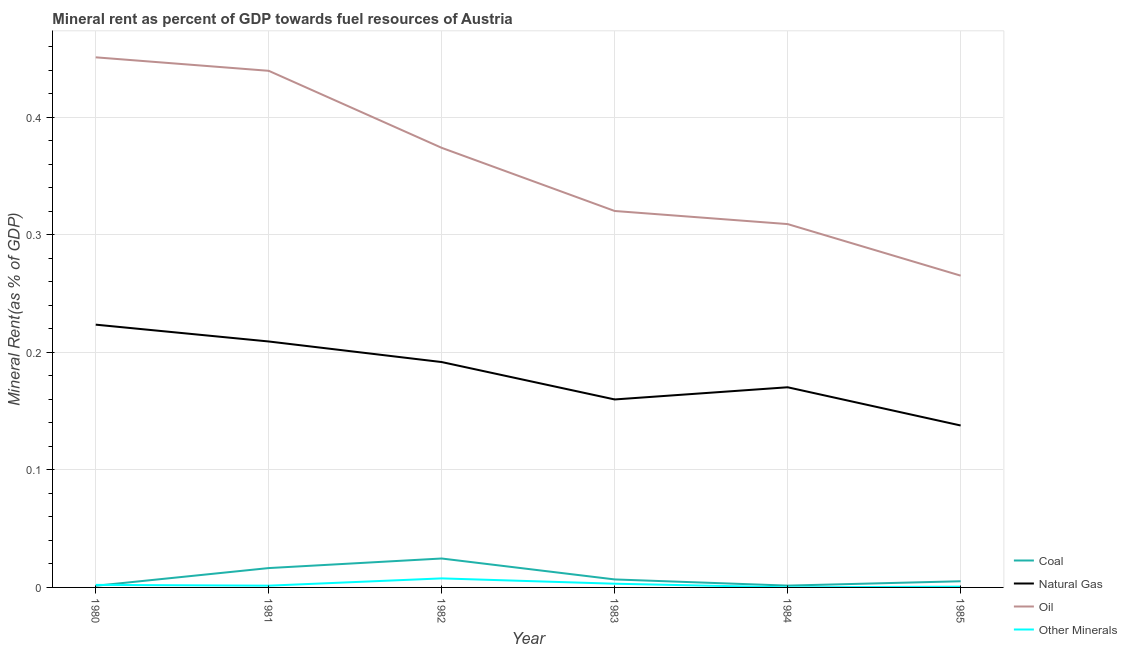What is the oil rent in 1981?
Provide a succinct answer. 0.44. Across all years, what is the maximum oil rent?
Keep it short and to the point. 0.45. Across all years, what is the minimum natural gas rent?
Your response must be concise. 0.14. In which year was the coal rent maximum?
Keep it short and to the point. 1982. In which year was the  rent of other minerals minimum?
Your answer should be compact. 1984. What is the total oil rent in the graph?
Your response must be concise. 2.16. What is the difference between the natural gas rent in 1980 and that in 1983?
Keep it short and to the point. 0.06. What is the difference between the oil rent in 1984 and the natural gas rent in 1981?
Offer a very short reply. 0.1. What is the average oil rent per year?
Your answer should be very brief. 0.36. In the year 1982, what is the difference between the natural gas rent and  rent of other minerals?
Give a very brief answer. 0.18. What is the ratio of the  rent of other minerals in 1981 to that in 1984?
Provide a succinct answer. 17.1. Is the difference between the coal rent in 1981 and 1985 greater than the difference between the oil rent in 1981 and 1985?
Your response must be concise. No. What is the difference between the highest and the second highest oil rent?
Ensure brevity in your answer.  0.01. What is the difference between the highest and the lowest natural gas rent?
Give a very brief answer. 0.09. Is the sum of the oil rent in 1981 and 1984 greater than the maximum natural gas rent across all years?
Keep it short and to the point. Yes. Does the  rent of other minerals monotonically increase over the years?
Give a very brief answer. No. Is the oil rent strictly greater than the coal rent over the years?
Ensure brevity in your answer.  Yes. How many years are there in the graph?
Ensure brevity in your answer.  6. What is the difference between two consecutive major ticks on the Y-axis?
Offer a very short reply. 0.1. Does the graph contain grids?
Offer a very short reply. Yes. Where does the legend appear in the graph?
Offer a very short reply. Bottom right. How many legend labels are there?
Provide a succinct answer. 4. How are the legend labels stacked?
Give a very brief answer. Vertical. What is the title of the graph?
Your answer should be compact. Mineral rent as percent of GDP towards fuel resources of Austria. What is the label or title of the X-axis?
Ensure brevity in your answer.  Year. What is the label or title of the Y-axis?
Your answer should be compact. Mineral Rent(as % of GDP). What is the Mineral Rent(as % of GDP) of Coal in 1980?
Make the answer very short. 0. What is the Mineral Rent(as % of GDP) of Natural Gas in 1980?
Give a very brief answer. 0.22. What is the Mineral Rent(as % of GDP) of Oil in 1980?
Keep it short and to the point. 0.45. What is the Mineral Rent(as % of GDP) of Other Minerals in 1980?
Ensure brevity in your answer.  0. What is the Mineral Rent(as % of GDP) of Coal in 1981?
Offer a terse response. 0.02. What is the Mineral Rent(as % of GDP) of Natural Gas in 1981?
Offer a terse response. 0.21. What is the Mineral Rent(as % of GDP) of Oil in 1981?
Your answer should be very brief. 0.44. What is the Mineral Rent(as % of GDP) of Other Minerals in 1981?
Provide a succinct answer. 0. What is the Mineral Rent(as % of GDP) of Coal in 1982?
Keep it short and to the point. 0.02. What is the Mineral Rent(as % of GDP) of Natural Gas in 1982?
Offer a terse response. 0.19. What is the Mineral Rent(as % of GDP) in Oil in 1982?
Provide a succinct answer. 0.37. What is the Mineral Rent(as % of GDP) in Other Minerals in 1982?
Ensure brevity in your answer.  0.01. What is the Mineral Rent(as % of GDP) in Coal in 1983?
Your response must be concise. 0.01. What is the Mineral Rent(as % of GDP) in Natural Gas in 1983?
Offer a terse response. 0.16. What is the Mineral Rent(as % of GDP) of Oil in 1983?
Keep it short and to the point. 0.32. What is the Mineral Rent(as % of GDP) of Other Minerals in 1983?
Make the answer very short. 0. What is the Mineral Rent(as % of GDP) of Coal in 1984?
Offer a terse response. 0. What is the Mineral Rent(as % of GDP) of Natural Gas in 1984?
Your answer should be compact. 0.17. What is the Mineral Rent(as % of GDP) in Oil in 1984?
Your answer should be very brief. 0.31. What is the Mineral Rent(as % of GDP) in Other Minerals in 1984?
Provide a succinct answer. 8.70112299928104e-5. What is the Mineral Rent(as % of GDP) in Coal in 1985?
Provide a succinct answer. 0.01. What is the Mineral Rent(as % of GDP) in Natural Gas in 1985?
Your answer should be compact. 0.14. What is the Mineral Rent(as % of GDP) of Oil in 1985?
Provide a short and direct response. 0.27. What is the Mineral Rent(as % of GDP) of Other Minerals in 1985?
Offer a very short reply. 0. Across all years, what is the maximum Mineral Rent(as % of GDP) in Coal?
Offer a very short reply. 0.02. Across all years, what is the maximum Mineral Rent(as % of GDP) in Natural Gas?
Provide a succinct answer. 0.22. Across all years, what is the maximum Mineral Rent(as % of GDP) of Oil?
Give a very brief answer. 0.45. Across all years, what is the maximum Mineral Rent(as % of GDP) of Other Minerals?
Make the answer very short. 0.01. Across all years, what is the minimum Mineral Rent(as % of GDP) in Coal?
Provide a succinct answer. 0. Across all years, what is the minimum Mineral Rent(as % of GDP) in Natural Gas?
Your response must be concise. 0.14. Across all years, what is the minimum Mineral Rent(as % of GDP) of Oil?
Make the answer very short. 0.27. Across all years, what is the minimum Mineral Rent(as % of GDP) of Other Minerals?
Provide a succinct answer. 8.70112299928104e-5. What is the total Mineral Rent(as % of GDP) of Coal in the graph?
Make the answer very short. 0.06. What is the total Mineral Rent(as % of GDP) of Natural Gas in the graph?
Your answer should be very brief. 1.09. What is the total Mineral Rent(as % of GDP) of Oil in the graph?
Your answer should be compact. 2.16. What is the total Mineral Rent(as % of GDP) of Other Minerals in the graph?
Ensure brevity in your answer.  0.02. What is the difference between the Mineral Rent(as % of GDP) of Coal in 1980 and that in 1981?
Keep it short and to the point. -0.02. What is the difference between the Mineral Rent(as % of GDP) of Natural Gas in 1980 and that in 1981?
Ensure brevity in your answer.  0.01. What is the difference between the Mineral Rent(as % of GDP) of Oil in 1980 and that in 1981?
Offer a terse response. 0.01. What is the difference between the Mineral Rent(as % of GDP) in Other Minerals in 1980 and that in 1981?
Your response must be concise. 0. What is the difference between the Mineral Rent(as % of GDP) of Coal in 1980 and that in 1982?
Provide a short and direct response. -0.02. What is the difference between the Mineral Rent(as % of GDP) of Natural Gas in 1980 and that in 1982?
Make the answer very short. 0.03. What is the difference between the Mineral Rent(as % of GDP) of Oil in 1980 and that in 1982?
Offer a terse response. 0.08. What is the difference between the Mineral Rent(as % of GDP) of Other Minerals in 1980 and that in 1982?
Your response must be concise. -0.01. What is the difference between the Mineral Rent(as % of GDP) of Coal in 1980 and that in 1983?
Offer a very short reply. -0.01. What is the difference between the Mineral Rent(as % of GDP) of Natural Gas in 1980 and that in 1983?
Your response must be concise. 0.06. What is the difference between the Mineral Rent(as % of GDP) in Oil in 1980 and that in 1983?
Keep it short and to the point. 0.13. What is the difference between the Mineral Rent(as % of GDP) of Other Minerals in 1980 and that in 1983?
Give a very brief answer. -0. What is the difference between the Mineral Rent(as % of GDP) in Coal in 1980 and that in 1984?
Your answer should be compact. -0. What is the difference between the Mineral Rent(as % of GDP) in Natural Gas in 1980 and that in 1984?
Your answer should be compact. 0.05. What is the difference between the Mineral Rent(as % of GDP) of Oil in 1980 and that in 1984?
Make the answer very short. 0.14. What is the difference between the Mineral Rent(as % of GDP) of Other Minerals in 1980 and that in 1984?
Offer a terse response. 0. What is the difference between the Mineral Rent(as % of GDP) in Coal in 1980 and that in 1985?
Provide a succinct answer. -0. What is the difference between the Mineral Rent(as % of GDP) in Natural Gas in 1980 and that in 1985?
Provide a short and direct response. 0.09. What is the difference between the Mineral Rent(as % of GDP) in Oil in 1980 and that in 1985?
Offer a terse response. 0.19. What is the difference between the Mineral Rent(as % of GDP) of Other Minerals in 1980 and that in 1985?
Ensure brevity in your answer.  0. What is the difference between the Mineral Rent(as % of GDP) in Coal in 1981 and that in 1982?
Ensure brevity in your answer.  -0.01. What is the difference between the Mineral Rent(as % of GDP) of Natural Gas in 1981 and that in 1982?
Offer a terse response. 0.02. What is the difference between the Mineral Rent(as % of GDP) of Oil in 1981 and that in 1982?
Provide a succinct answer. 0.07. What is the difference between the Mineral Rent(as % of GDP) in Other Minerals in 1981 and that in 1982?
Your response must be concise. -0.01. What is the difference between the Mineral Rent(as % of GDP) in Coal in 1981 and that in 1983?
Ensure brevity in your answer.  0.01. What is the difference between the Mineral Rent(as % of GDP) of Natural Gas in 1981 and that in 1983?
Make the answer very short. 0.05. What is the difference between the Mineral Rent(as % of GDP) of Oil in 1981 and that in 1983?
Ensure brevity in your answer.  0.12. What is the difference between the Mineral Rent(as % of GDP) of Other Minerals in 1981 and that in 1983?
Provide a short and direct response. -0. What is the difference between the Mineral Rent(as % of GDP) in Coal in 1981 and that in 1984?
Keep it short and to the point. 0.01. What is the difference between the Mineral Rent(as % of GDP) of Natural Gas in 1981 and that in 1984?
Ensure brevity in your answer.  0.04. What is the difference between the Mineral Rent(as % of GDP) of Oil in 1981 and that in 1984?
Give a very brief answer. 0.13. What is the difference between the Mineral Rent(as % of GDP) in Other Minerals in 1981 and that in 1984?
Ensure brevity in your answer.  0. What is the difference between the Mineral Rent(as % of GDP) in Coal in 1981 and that in 1985?
Your response must be concise. 0.01. What is the difference between the Mineral Rent(as % of GDP) of Natural Gas in 1981 and that in 1985?
Keep it short and to the point. 0.07. What is the difference between the Mineral Rent(as % of GDP) in Oil in 1981 and that in 1985?
Your response must be concise. 0.17. What is the difference between the Mineral Rent(as % of GDP) of Other Minerals in 1981 and that in 1985?
Your response must be concise. 0. What is the difference between the Mineral Rent(as % of GDP) of Coal in 1982 and that in 1983?
Make the answer very short. 0.02. What is the difference between the Mineral Rent(as % of GDP) in Natural Gas in 1982 and that in 1983?
Provide a succinct answer. 0.03. What is the difference between the Mineral Rent(as % of GDP) of Oil in 1982 and that in 1983?
Ensure brevity in your answer.  0.05. What is the difference between the Mineral Rent(as % of GDP) of Other Minerals in 1982 and that in 1983?
Keep it short and to the point. 0. What is the difference between the Mineral Rent(as % of GDP) in Coal in 1982 and that in 1984?
Your answer should be compact. 0.02. What is the difference between the Mineral Rent(as % of GDP) in Natural Gas in 1982 and that in 1984?
Offer a very short reply. 0.02. What is the difference between the Mineral Rent(as % of GDP) in Oil in 1982 and that in 1984?
Ensure brevity in your answer.  0.06. What is the difference between the Mineral Rent(as % of GDP) in Other Minerals in 1982 and that in 1984?
Offer a terse response. 0.01. What is the difference between the Mineral Rent(as % of GDP) of Coal in 1982 and that in 1985?
Ensure brevity in your answer.  0.02. What is the difference between the Mineral Rent(as % of GDP) in Natural Gas in 1982 and that in 1985?
Ensure brevity in your answer.  0.05. What is the difference between the Mineral Rent(as % of GDP) of Oil in 1982 and that in 1985?
Ensure brevity in your answer.  0.11. What is the difference between the Mineral Rent(as % of GDP) of Other Minerals in 1982 and that in 1985?
Keep it short and to the point. 0.01. What is the difference between the Mineral Rent(as % of GDP) in Coal in 1983 and that in 1984?
Your response must be concise. 0.01. What is the difference between the Mineral Rent(as % of GDP) of Natural Gas in 1983 and that in 1984?
Give a very brief answer. -0.01. What is the difference between the Mineral Rent(as % of GDP) in Oil in 1983 and that in 1984?
Keep it short and to the point. 0.01. What is the difference between the Mineral Rent(as % of GDP) of Other Minerals in 1983 and that in 1984?
Provide a succinct answer. 0. What is the difference between the Mineral Rent(as % of GDP) of Coal in 1983 and that in 1985?
Give a very brief answer. 0. What is the difference between the Mineral Rent(as % of GDP) in Natural Gas in 1983 and that in 1985?
Your answer should be very brief. 0.02. What is the difference between the Mineral Rent(as % of GDP) of Oil in 1983 and that in 1985?
Make the answer very short. 0.06. What is the difference between the Mineral Rent(as % of GDP) in Other Minerals in 1983 and that in 1985?
Keep it short and to the point. 0. What is the difference between the Mineral Rent(as % of GDP) of Coal in 1984 and that in 1985?
Provide a succinct answer. -0. What is the difference between the Mineral Rent(as % of GDP) of Natural Gas in 1984 and that in 1985?
Make the answer very short. 0.03. What is the difference between the Mineral Rent(as % of GDP) of Oil in 1984 and that in 1985?
Your answer should be very brief. 0.04. What is the difference between the Mineral Rent(as % of GDP) of Other Minerals in 1984 and that in 1985?
Offer a very short reply. -0. What is the difference between the Mineral Rent(as % of GDP) in Coal in 1980 and the Mineral Rent(as % of GDP) in Natural Gas in 1981?
Offer a very short reply. -0.21. What is the difference between the Mineral Rent(as % of GDP) in Coal in 1980 and the Mineral Rent(as % of GDP) in Oil in 1981?
Your response must be concise. -0.44. What is the difference between the Mineral Rent(as % of GDP) of Coal in 1980 and the Mineral Rent(as % of GDP) of Other Minerals in 1981?
Provide a short and direct response. -0. What is the difference between the Mineral Rent(as % of GDP) of Natural Gas in 1980 and the Mineral Rent(as % of GDP) of Oil in 1981?
Give a very brief answer. -0.22. What is the difference between the Mineral Rent(as % of GDP) of Natural Gas in 1980 and the Mineral Rent(as % of GDP) of Other Minerals in 1981?
Your answer should be very brief. 0.22. What is the difference between the Mineral Rent(as % of GDP) in Oil in 1980 and the Mineral Rent(as % of GDP) in Other Minerals in 1981?
Ensure brevity in your answer.  0.45. What is the difference between the Mineral Rent(as % of GDP) of Coal in 1980 and the Mineral Rent(as % of GDP) of Natural Gas in 1982?
Offer a very short reply. -0.19. What is the difference between the Mineral Rent(as % of GDP) of Coal in 1980 and the Mineral Rent(as % of GDP) of Oil in 1982?
Your answer should be compact. -0.37. What is the difference between the Mineral Rent(as % of GDP) in Coal in 1980 and the Mineral Rent(as % of GDP) in Other Minerals in 1982?
Your answer should be compact. -0.01. What is the difference between the Mineral Rent(as % of GDP) of Natural Gas in 1980 and the Mineral Rent(as % of GDP) of Oil in 1982?
Provide a short and direct response. -0.15. What is the difference between the Mineral Rent(as % of GDP) of Natural Gas in 1980 and the Mineral Rent(as % of GDP) of Other Minerals in 1982?
Ensure brevity in your answer.  0.22. What is the difference between the Mineral Rent(as % of GDP) of Oil in 1980 and the Mineral Rent(as % of GDP) of Other Minerals in 1982?
Your answer should be very brief. 0.44. What is the difference between the Mineral Rent(as % of GDP) of Coal in 1980 and the Mineral Rent(as % of GDP) of Natural Gas in 1983?
Ensure brevity in your answer.  -0.16. What is the difference between the Mineral Rent(as % of GDP) of Coal in 1980 and the Mineral Rent(as % of GDP) of Oil in 1983?
Offer a terse response. -0.32. What is the difference between the Mineral Rent(as % of GDP) in Coal in 1980 and the Mineral Rent(as % of GDP) in Other Minerals in 1983?
Offer a terse response. -0. What is the difference between the Mineral Rent(as % of GDP) of Natural Gas in 1980 and the Mineral Rent(as % of GDP) of Oil in 1983?
Keep it short and to the point. -0.1. What is the difference between the Mineral Rent(as % of GDP) in Natural Gas in 1980 and the Mineral Rent(as % of GDP) in Other Minerals in 1983?
Provide a short and direct response. 0.22. What is the difference between the Mineral Rent(as % of GDP) of Oil in 1980 and the Mineral Rent(as % of GDP) of Other Minerals in 1983?
Provide a short and direct response. 0.45. What is the difference between the Mineral Rent(as % of GDP) of Coal in 1980 and the Mineral Rent(as % of GDP) of Natural Gas in 1984?
Ensure brevity in your answer.  -0.17. What is the difference between the Mineral Rent(as % of GDP) of Coal in 1980 and the Mineral Rent(as % of GDP) of Oil in 1984?
Provide a succinct answer. -0.31. What is the difference between the Mineral Rent(as % of GDP) of Coal in 1980 and the Mineral Rent(as % of GDP) of Other Minerals in 1984?
Your answer should be compact. 0. What is the difference between the Mineral Rent(as % of GDP) in Natural Gas in 1980 and the Mineral Rent(as % of GDP) in Oil in 1984?
Offer a terse response. -0.09. What is the difference between the Mineral Rent(as % of GDP) of Natural Gas in 1980 and the Mineral Rent(as % of GDP) of Other Minerals in 1984?
Provide a succinct answer. 0.22. What is the difference between the Mineral Rent(as % of GDP) in Oil in 1980 and the Mineral Rent(as % of GDP) in Other Minerals in 1984?
Provide a short and direct response. 0.45. What is the difference between the Mineral Rent(as % of GDP) of Coal in 1980 and the Mineral Rent(as % of GDP) of Natural Gas in 1985?
Make the answer very short. -0.14. What is the difference between the Mineral Rent(as % of GDP) in Coal in 1980 and the Mineral Rent(as % of GDP) in Oil in 1985?
Provide a succinct answer. -0.26. What is the difference between the Mineral Rent(as % of GDP) in Coal in 1980 and the Mineral Rent(as % of GDP) in Other Minerals in 1985?
Provide a short and direct response. 0. What is the difference between the Mineral Rent(as % of GDP) of Natural Gas in 1980 and the Mineral Rent(as % of GDP) of Oil in 1985?
Offer a very short reply. -0.04. What is the difference between the Mineral Rent(as % of GDP) of Natural Gas in 1980 and the Mineral Rent(as % of GDP) of Other Minerals in 1985?
Your answer should be very brief. 0.22. What is the difference between the Mineral Rent(as % of GDP) in Oil in 1980 and the Mineral Rent(as % of GDP) in Other Minerals in 1985?
Your answer should be very brief. 0.45. What is the difference between the Mineral Rent(as % of GDP) of Coal in 1981 and the Mineral Rent(as % of GDP) of Natural Gas in 1982?
Offer a terse response. -0.18. What is the difference between the Mineral Rent(as % of GDP) of Coal in 1981 and the Mineral Rent(as % of GDP) of Oil in 1982?
Ensure brevity in your answer.  -0.36. What is the difference between the Mineral Rent(as % of GDP) in Coal in 1981 and the Mineral Rent(as % of GDP) in Other Minerals in 1982?
Ensure brevity in your answer.  0.01. What is the difference between the Mineral Rent(as % of GDP) in Natural Gas in 1981 and the Mineral Rent(as % of GDP) in Oil in 1982?
Provide a succinct answer. -0.16. What is the difference between the Mineral Rent(as % of GDP) of Natural Gas in 1981 and the Mineral Rent(as % of GDP) of Other Minerals in 1982?
Give a very brief answer. 0.2. What is the difference between the Mineral Rent(as % of GDP) in Oil in 1981 and the Mineral Rent(as % of GDP) in Other Minerals in 1982?
Provide a short and direct response. 0.43. What is the difference between the Mineral Rent(as % of GDP) in Coal in 1981 and the Mineral Rent(as % of GDP) in Natural Gas in 1983?
Offer a very short reply. -0.14. What is the difference between the Mineral Rent(as % of GDP) in Coal in 1981 and the Mineral Rent(as % of GDP) in Oil in 1983?
Ensure brevity in your answer.  -0.3. What is the difference between the Mineral Rent(as % of GDP) in Coal in 1981 and the Mineral Rent(as % of GDP) in Other Minerals in 1983?
Make the answer very short. 0.01. What is the difference between the Mineral Rent(as % of GDP) in Natural Gas in 1981 and the Mineral Rent(as % of GDP) in Oil in 1983?
Keep it short and to the point. -0.11. What is the difference between the Mineral Rent(as % of GDP) in Natural Gas in 1981 and the Mineral Rent(as % of GDP) in Other Minerals in 1983?
Provide a short and direct response. 0.21. What is the difference between the Mineral Rent(as % of GDP) of Oil in 1981 and the Mineral Rent(as % of GDP) of Other Minerals in 1983?
Offer a very short reply. 0.44. What is the difference between the Mineral Rent(as % of GDP) of Coal in 1981 and the Mineral Rent(as % of GDP) of Natural Gas in 1984?
Offer a terse response. -0.15. What is the difference between the Mineral Rent(as % of GDP) in Coal in 1981 and the Mineral Rent(as % of GDP) in Oil in 1984?
Your answer should be very brief. -0.29. What is the difference between the Mineral Rent(as % of GDP) of Coal in 1981 and the Mineral Rent(as % of GDP) of Other Minerals in 1984?
Offer a terse response. 0.02. What is the difference between the Mineral Rent(as % of GDP) of Natural Gas in 1981 and the Mineral Rent(as % of GDP) of Oil in 1984?
Provide a succinct answer. -0.1. What is the difference between the Mineral Rent(as % of GDP) in Natural Gas in 1981 and the Mineral Rent(as % of GDP) in Other Minerals in 1984?
Offer a very short reply. 0.21. What is the difference between the Mineral Rent(as % of GDP) in Oil in 1981 and the Mineral Rent(as % of GDP) in Other Minerals in 1984?
Offer a terse response. 0.44. What is the difference between the Mineral Rent(as % of GDP) in Coal in 1981 and the Mineral Rent(as % of GDP) in Natural Gas in 1985?
Provide a short and direct response. -0.12. What is the difference between the Mineral Rent(as % of GDP) of Coal in 1981 and the Mineral Rent(as % of GDP) of Oil in 1985?
Ensure brevity in your answer.  -0.25. What is the difference between the Mineral Rent(as % of GDP) in Coal in 1981 and the Mineral Rent(as % of GDP) in Other Minerals in 1985?
Ensure brevity in your answer.  0.02. What is the difference between the Mineral Rent(as % of GDP) in Natural Gas in 1981 and the Mineral Rent(as % of GDP) in Oil in 1985?
Your answer should be very brief. -0.06. What is the difference between the Mineral Rent(as % of GDP) of Natural Gas in 1981 and the Mineral Rent(as % of GDP) of Other Minerals in 1985?
Your answer should be compact. 0.21. What is the difference between the Mineral Rent(as % of GDP) of Oil in 1981 and the Mineral Rent(as % of GDP) of Other Minerals in 1985?
Offer a terse response. 0.44. What is the difference between the Mineral Rent(as % of GDP) of Coal in 1982 and the Mineral Rent(as % of GDP) of Natural Gas in 1983?
Provide a short and direct response. -0.14. What is the difference between the Mineral Rent(as % of GDP) in Coal in 1982 and the Mineral Rent(as % of GDP) in Oil in 1983?
Offer a very short reply. -0.3. What is the difference between the Mineral Rent(as % of GDP) in Coal in 1982 and the Mineral Rent(as % of GDP) in Other Minerals in 1983?
Make the answer very short. 0.02. What is the difference between the Mineral Rent(as % of GDP) of Natural Gas in 1982 and the Mineral Rent(as % of GDP) of Oil in 1983?
Your answer should be very brief. -0.13. What is the difference between the Mineral Rent(as % of GDP) in Natural Gas in 1982 and the Mineral Rent(as % of GDP) in Other Minerals in 1983?
Keep it short and to the point. 0.19. What is the difference between the Mineral Rent(as % of GDP) in Oil in 1982 and the Mineral Rent(as % of GDP) in Other Minerals in 1983?
Your answer should be very brief. 0.37. What is the difference between the Mineral Rent(as % of GDP) of Coal in 1982 and the Mineral Rent(as % of GDP) of Natural Gas in 1984?
Ensure brevity in your answer.  -0.15. What is the difference between the Mineral Rent(as % of GDP) of Coal in 1982 and the Mineral Rent(as % of GDP) of Oil in 1984?
Offer a terse response. -0.28. What is the difference between the Mineral Rent(as % of GDP) of Coal in 1982 and the Mineral Rent(as % of GDP) of Other Minerals in 1984?
Offer a terse response. 0.02. What is the difference between the Mineral Rent(as % of GDP) in Natural Gas in 1982 and the Mineral Rent(as % of GDP) in Oil in 1984?
Your answer should be very brief. -0.12. What is the difference between the Mineral Rent(as % of GDP) of Natural Gas in 1982 and the Mineral Rent(as % of GDP) of Other Minerals in 1984?
Offer a terse response. 0.19. What is the difference between the Mineral Rent(as % of GDP) in Oil in 1982 and the Mineral Rent(as % of GDP) in Other Minerals in 1984?
Give a very brief answer. 0.37. What is the difference between the Mineral Rent(as % of GDP) of Coal in 1982 and the Mineral Rent(as % of GDP) of Natural Gas in 1985?
Make the answer very short. -0.11. What is the difference between the Mineral Rent(as % of GDP) of Coal in 1982 and the Mineral Rent(as % of GDP) of Oil in 1985?
Provide a short and direct response. -0.24. What is the difference between the Mineral Rent(as % of GDP) in Coal in 1982 and the Mineral Rent(as % of GDP) in Other Minerals in 1985?
Provide a succinct answer. 0.02. What is the difference between the Mineral Rent(as % of GDP) of Natural Gas in 1982 and the Mineral Rent(as % of GDP) of Oil in 1985?
Your answer should be compact. -0.07. What is the difference between the Mineral Rent(as % of GDP) in Natural Gas in 1982 and the Mineral Rent(as % of GDP) in Other Minerals in 1985?
Offer a very short reply. 0.19. What is the difference between the Mineral Rent(as % of GDP) in Oil in 1982 and the Mineral Rent(as % of GDP) in Other Minerals in 1985?
Your answer should be compact. 0.37. What is the difference between the Mineral Rent(as % of GDP) in Coal in 1983 and the Mineral Rent(as % of GDP) in Natural Gas in 1984?
Offer a very short reply. -0.16. What is the difference between the Mineral Rent(as % of GDP) in Coal in 1983 and the Mineral Rent(as % of GDP) in Oil in 1984?
Provide a short and direct response. -0.3. What is the difference between the Mineral Rent(as % of GDP) of Coal in 1983 and the Mineral Rent(as % of GDP) of Other Minerals in 1984?
Your answer should be very brief. 0.01. What is the difference between the Mineral Rent(as % of GDP) in Natural Gas in 1983 and the Mineral Rent(as % of GDP) in Oil in 1984?
Provide a short and direct response. -0.15. What is the difference between the Mineral Rent(as % of GDP) of Natural Gas in 1983 and the Mineral Rent(as % of GDP) of Other Minerals in 1984?
Ensure brevity in your answer.  0.16. What is the difference between the Mineral Rent(as % of GDP) of Oil in 1983 and the Mineral Rent(as % of GDP) of Other Minerals in 1984?
Give a very brief answer. 0.32. What is the difference between the Mineral Rent(as % of GDP) of Coal in 1983 and the Mineral Rent(as % of GDP) of Natural Gas in 1985?
Give a very brief answer. -0.13. What is the difference between the Mineral Rent(as % of GDP) in Coal in 1983 and the Mineral Rent(as % of GDP) in Oil in 1985?
Give a very brief answer. -0.26. What is the difference between the Mineral Rent(as % of GDP) in Coal in 1983 and the Mineral Rent(as % of GDP) in Other Minerals in 1985?
Your answer should be compact. 0.01. What is the difference between the Mineral Rent(as % of GDP) in Natural Gas in 1983 and the Mineral Rent(as % of GDP) in Oil in 1985?
Offer a very short reply. -0.11. What is the difference between the Mineral Rent(as % of GDP) in Natural Gas in 1983 and the Mineral Rent(as % of GDP) in Other Minerals in 1985?
Ensure brevity in your answer.  0.16. What is the difference between the Mineral Rent(as % of GDP) of Oil in 1983 and the Mineral Rent(as % of GDP) of Other Minerals in 1985?
Keep it short and to the point. 0.32. What is the difference between the Mineral Rent(as % of GDP) in Coal in 1984 and the Mineral Rent(as % of GDP) in Natural Gas in 1985?
Ensure brevity in your answer.  -0.14. What is the difference between the Mineral Rent(as % of GDP) of Coal in 1984 and the Mineral Rent(as % of GDP) of Oil in 1985?
Offer a very short reply. -0.26. What is the difference between the Mineral Rent(as % of GDP) of Coal in 1984 and the Mineral Rent(as % of GDP) of Other Minerals in 1985?
Offer a terse response. 0. What is the difference between the Mineral Rent(as % of GDP) in Natural Gas in 1984 and the Mineral Rent(as % of GDP) in Oil in 1985?
Provide a short and direct response. -0.1. What is the difference between the Mineral Rent(as % of GDP) of Natural Gas in 1984 and the Mineral Rent(as % of GDP) of Other Minerals in 1985?
Offer a terse response. 0.17. What is the difference between the Mineral Rent(as % of GDP) in Oil in 1984 and the Mineral Rent(as % of GDP) in Other Minerals in 1985?
Provide a short and direct response. 0.31. What is the average Mineral Rent(as % of GDP) of Coal per year?
Your answer should be compact. 0.01. What is the average Mineral Rent(as % of GDP) in Natural Gas per year?
Offer a very short reply. 0.18. What is the average Mineral Rent(as % of GDP) of Oil per year?
Give a very brief answer. 0.36. What is the average Mineral Rent(as % of GDP) of Other Minerals per year?
Offer a very short reply. 0. In the year 1980, what is the difference between the Mineral Rent(as % of GDP) of Coal and Mineral Rent(as % of GDP) of Natural Gas?
Ensure brevity in your answer.  -0.22. In the year 1980, what is the difference between the Mineral Rent(as % of GDP) in Coal and Mineral Rent(as % of GDP) in Oil?
Keep it short and to the point. -0.45. In the year 1980, what is the difference between the Mineral Rent(as % of GDP) of Coal and Mineral Rent(as % of GDP) of Other Minerals?
Provide a succinct answer. -0. In the year 1980, what is the difference between the Mineral Rent(as % of GDP) in Natural Gas and Mineral Rent(as % of GDP) in Oil?
Provide a short and direct response. -0.23. In the year 1980, what is the difference between the Mineral Rent(as % of GDP) of Natural Gas and Mineral Rent(as % of GDP) of Other Minerals?
Offer a terse response. 0.22. In the year 1980, what is the difference between the Mineral Rent(as % of GDP) in Oil and Mineral Rent(as % of GDP) in Other Minerals?
Your answer should be compact. 0.45. In the year 1981, what is the difference between the Mineral Rent(as % of GDP) of Coal and Mineral Rent(as % of GDP) of Natural Gas?
Your answer should be compact. -0.19. In the year 1981, what is the difference between the Mineral Rent(as % of GDP) of Coal and Mineral Rent(as % of GDP) of Oil?
Your answer should be compact. -0.42. In the year 1981, what is the difference between the Mineral Rent(as % of GDP) in Coal and Mineral Rent(as % of GDP) in Other Minerals?
Keep it short and to the point. 0.01. In the year 1981, what is the difference between the Mineral Rent(as % of GDP) of Natural Gas and Mineral Rent(as % of GDP) of Oil?
Offer a very short reply. -0.23. In the year 1981, what is the difference between the Mineral Rent(as % of GDP) of Natural Gas and Mineral Rent(as % of GDP) of Other Minerals?
Provide a succinct answer. 0.21. In the year 1981, what is the difference between the Mineral Rent(as % of GDP) in Oil and Mineral Rent(as % of GDP) in Other Minerals?
Make the answer very short. 0.44. In the year 1982, what is the difference between the Mineral Rent(as % of GDP) in Coal and Mineral Rent(as % of GDP) in Natural Gas?
Make the answer very short. -0.17. In the year 1982, what is the difference between the Mineral Rent(as % of GDP) in Coal and Mineral Rent(as % of GDP) in Oil?
Ensure brevity in your answer.  -0.35. In the year 1982, what is the difference between the Mineral Rent(as % of GDP) of Coal and Mineral Rent(as % of GDP) of Other Minerals?
Provide a succinct answer. 0.02. In the year 1982, what is the difference between the Mineral Rent(as % of GDP) of Natural Gas and Mineral Rent(as % of GDP) of Oil?
Offer a very short reply. -0.18. In the year 1982, what is the difference between the Mineral Rent(as % of GDP) in Natural Gas and Mineral Rent(as % of GDP) in Other Minerals?
Provide a succinct answer. 0.18. In the year 1982, what is the difference between the Mineral Rent(as % of GDP) of Oil and Mineral Rent(as % of GDP) of Other Minerals?
Provide a succinct answer. 0.37. In the year 1983, what is the difference between the Mineral Rent(as % of GDP) of Coal and Mineral Rent(as % of GDP) of Natural Gas?
Make the answer very short. -0.15. In the year 1983, what is the difference between the Mineral Rent(as % of GDP) of Coal and Mineral Rent(as % of GDP) of Oil?
Make the answer very short. -0.31. In the year 1983, what is the difference between the Mineral Rent(as % of GDP) in Coal and Mineral Rent(as % of GDP) in Other Minerals?
Offer a terse response. 0. In the year 1983, what is the difference between the Mineral Rent(as % of GDP) in Natural Gas and Mineral Rent(as % of GDP) in Oil?
Your answer should be compact. -0.16. In the year 1983, what is the difference between the Mineral Rent(as % of GDP) of Natural Gas and Mineral Rent(as % of GDP) of Other Minerals?
Provide a succinct answer. 0.16. In the year 1983, what is the difference between the Mineral Rent(as % of GDP) of Oil and Mineral Rent(as % of GDP) of Other Minerals?
Keep it short and to the point. 0.32. In the year 1984, what is the difference between the Mineral Rent(as % of GDP) in Coal and Mineral Rent(as % of GDP) in Natural Gas?
Provide a short and direct response. -0.17. In the year 1984, what is the difference between the Mineral Rent(as % of GDP) of Coal and Mineral Rent(as % of GDP) of Oil?
Keep it short and to the point. -0.31. In the year 1984, what is the difference between the Mineral Rent(as % of GDP) in Coal and Mineral Rent(as % of GDP) in Other Minerals?
Your answer should be compact. 0. In the year 1984, what is the difference between the Mineral Rent(as % of GDP) of Natural Gas and Mineral Rent(as % of GDP) of Oil?
Offer a very short reply. -0.14. In the year 1984, what is the difference between the Mineral Rent(as % of GDP) in Natural Gas and Mineral Rent(as % of GDP) in Other Minerals?
Your answer should be very brief. 0.17. In the year 1984, what is the difference between the Mineral Rent(as % of GDP) of Oil and Mineral Rent(as % of GDP) of Other Minerals?
Make the answer very short. 0.31. In the year 1985, what is the difference between the Mineral Rent(as % of GDP) in Coal and Mineral Rent(as % of GDP) in Natural Gas?
Offer a very short reply. -0.13. In the year 1985, what is the difference between the Mineral Rent(as % of GDP) of Coal and Mineral Rent(as % of GDP) of Oil?
Your response must be concise. -0.26. In the year 1985, what is the difference between the Mineral Rent(as % of GDP) of Coal and Mineral Rent(as % of GDP) of Other Minerals?
Give a very brief answer. 0. In the year 1985, what is the difference between the Mineral Rent(as % of GDP) of Natural Gas and Mineral Rent(as % of GDP) of Oil?
Offer a very short reply. -0.13. In the year 1985, what is the difference between the Mineral Rent(as % of GDP) of Natural Gas and Mineral Rent(as % of GDP) of Other Minerals?
Your answer should be very brief. 0.14. In the year 1985, what is the difference between the Mineral Rent(as % of GDP) in Oil and Mineral Rent(as % of GDP) in Other Minerals?
Make the answer very short. 0.26. What is the ratio of the Mineral Rent(as % of GDP) in Coal in 1980 to that in 1981?
Keep it short and to the point. 0.09. What is the ratio of the Mineral Rent(as % of GDP) of Natural Gas in 1980 to that in 1981?
Give a very brief answer. 1.07. What is the ratio of the Mineral Rent(as % of GDP) in Oil in 1980 to that in 1981?
Your response must be concise. 1.03. What is the ratio of the Mineral Rent(as % of GDP) in Other Minerals in 1980 to that in 1981?
Provide a succinct answer. 1.46. What is the ratio of the Mineral Rent(as % of GDP) in Coal in 1980 to that in 1982?
Ensure brevity in your answer.  0.06. What is the ratio of the Mineral Rent(as % of GDP) in Natural Gas in 1980 to that in 1982?
Your response must be concise. 1.17. What is the ratio of the Mineral Rent(as % of GDP) in Oil in 1980 to that in 1982?
Offer a very short reply. 1.21. What is the ratio of the Mineral Rent(as % of GDP) of Other Minerals in 1980 to that in 1982?
Your answer should be very brief. 0.28. What is the ratio of the Mineral Rent(as % of GDP) of Coal in 1980 to that in 1983?
Provide a succinct answer. 0.21. What is the ratio of the Mineral Rent(as % of GDP) of Natural Gas in 1980 to that in 1983?
Your answer should be compact. 1.4. What is the ratio of the Mineral Rent(as % of GDP) of Oil in 1980 to that in 1983?
Your answer should be very brief. 1.41. What is the ratio of the Mineral Rent(as % of GDP) in Other Minerals in 1980 to that in 1983?
Offer a terse response. 0.69. What is the ratio of the Mineral Rent(as % of GDP) in Coal in 1980 to that in 1984?
Make the answer very short. 0.91. What is the ratio of the Mineral Rent(as % of GDP) of Natural Gas in 1980 to that in 1984?
Offer a terse response. 1.31. What is the ratio of the Mineral Rent(as % of GDP) of Oil in 1980 to that in 1984?
Ensure brevity in your answer.  1.46. What is the ratio of the Mineral Rent(as % of GDP) of Other Minerals in 1980 to that in 1984?
Make the answer very short. 24.88. What is the ratio of the Mineral Rent(as % of GDP) of Coal in 1980 to that in 1985?
Ensure brevity in your answer.  0.27. What is the ratio of the Mineral Rent(as % of GDP) in Natural Gas in 1980 to that in 1985?
Provide a short and direct response. 1.62. What is the ratio of the Mineral Rent(as % of GDP) of Oil in 1980 to that in 1985?
Give a very brief answer. 1.7. What is the ratio of the Mineral Rent(as % of GDP) of Other Minerals in 1980 to that in 1985?
Ensure brevity in your answer.  3.29. What is the ratio of the Mineral Rent(as % of GDP) in Coal in 1981 to that in 1982?
Provide a short and direct response. 0.67. What is the ratio of the Mineral Rent(as % of GDP) of Natural Gas in 1981 to that in 1982?
Your answer should be compact. 1.09. What is the ratio of the Mineral Rent(as % of GDP) in Oil in 1981 to that in 1982?
Your answer should be compact. 1.18. What is the ratio of the Mineral Rent(as % of GDP) in Other Minerals in 1981 to that in 1982?
Your response must be concise. 0.19. What is the ratio of the Mineral Rent(as % of GDP) in Coal in 1981 to that in 1983?
Keep it short and to the point. 2.42. What is the ratio of the Mineral Rent(as % of GDP) in Natural Gas in 1981 to that in 1983?
Give a very brief answer. 1.31. What is the ratio of the Mineral Rent(as % of GDP) in Oil in 1981 to that in 1983?
Offer a terse response. 1.37. What is the ratio of the Mineral Rent(as % of GDP) of Other Minerals in 1981 to that in 1983?
Offer a very short reply. 0.47. What is the ratio of the Mineral Rent(as % of GDP) of Coal in 1981 to that in 1984?
Provide a succinct answer. 10.69. What is the ratio of the Mineral Rent(as % of GDP) of Natural Gas in 1981 to that in 1984?
Your answer should be very brief. 1.23. What is the ratio of the Mineral Rent(as % of GDP) of Oil in 1981 to that in 1984?
Provide a short and direct response. 1.42. What is the ratio of the Mineral Rent(as % of GDP) in Other Minerals in 1981 to that in 1984?
Your answer should be very brief. 17.1. What is the ratio of the Mineral Rent(as % of GDP) in Coal in 1981 to that in 1985?
Your answer should be very brief. 3.13. What is the ratio of the Mineral Rent(as % of GDP) of Natural Gas in 1981 to that in 1985?
Ensure brevity in your answer.  1.52. What is the ratio of the Mineral Rent(as % of GDP) in Oil in 1981 to that in 1985?
Your answer should be very brief. 1.66. What is the ratio of the Mineral Rent(as % of GDP) in Other Minerals in 1981 to that in 1985?
Offer a terse response. 2.26. What is the ratio of the Mineral Rent(as % of GDP) in Coal in 1982 to that in 1983?
Make the answer very short. 3.62. What is the ratio of the Mineral Rent(as % of GDP) in Natural Gas in 1982 to that in 1983?
Your response must be concise. 1.2. What is the ratio of the Mineral Rent(as % of GDP) of Oil in 1982 to that in 1983?
Offer a very short reply. 1.17. What is the ratio of the Mineral Rent(as % of GDP) of Other Minerals in 1982 to that in 1983?
Provide a succinct answer. 2.44. What is the ratio of the Mineral Rent(as % of GDP) of Coal in 1982 to that in 1984?
Offer a very short reply. 15.97. What is the ratio of the Mineral Rent(as % of GDP) in Natural Gas in 1982 to that in 1984?
Ensure brevity in your answer.  1.13. What is the ratio of the Mineral Rent(as % of GDP) in Oil in 1982 to that in 1984?
Give a very brief answer. 1.21. What is the ratio of the Mineral Rent(as % of GDP) of Other Minerals in 1982 to that in 1984?
Your answer should be compact. 88.34. What is the ratio of the Mineral Rent(as % of GDP) of Coal in 1982 to that in 1985?
Give a very brief answer. 4.68. What is the ratio of the Mineral Rent(as % of GDP) of Natural Gas in 1982 to that in 1985?
Your answer should be very brief. 1.39. What is the ratio of the Mineral Rent(as % of GDP) in Oil in 1982 to that in 1985?
Your answer should be very brief. 1.41. What is the ratio of the Mineral Rent(as % of GDP) in Other Minerals in 1982 to that in 1985?
Offer a terse response. 11.68. What is the ratio of the Mineral Rent(as % of GDP) of Coal in 1983 to that in 1984?
Provide a short and direct response. 4.42. What is the ratio of the Mineral Rent(as % of GDP) of Natural Gas in 1983 to that in 1984?
Keep it short and to the point. 0.94. What is the ratio of the Mineral Rent(as % of GDP) of Oil in 1983 to that in 1984?
Ensure brevity in your answer.  1.04. What is the ratio of the Mineral Rent(as % of GDP) in Other Minerals in 1983 to that in 1984?
Your answer should be very brief. 36.2. What is the ratio of the Mineral Rent(as % of GDP) of Coal in 1983 to that in 1985?
Your response must be concise. 1.29. What is the ratio of the Mineral Rent(as % of GDP) of Natural Gas in 1983 to that in 1985?
Your response must be concise. 1.16. What is the ratio of the Mineral Rent(as % of GDP) in Oil in 1983 to that in 1985?
Provide a short and direct response. 1.21. What is the ratio of the Mineral Rent(as % of GDP) of Other Minerals in 1983 to that in 1985?
Your answer should be very brief. 4.79. What is the ratio of the Mineral Rent(as % of GDP) of Coal in 1984 to that in 1985?
Your answer should be very brief. 0.29. What is the ratio of the Mineral Rent(as % of GDP) of Natural Gas in 1984 to that in 1985?
Your response must be concise. 1.24. What is the ratio of the Mineral Rent(as % of GDP) of Oil in 1984 to that in 1985?
Offer a very short reply. 1.17. What is the ratio of the Mineral Rent(as % of GDP) of Other Minerals in 1984 to that in 1985?
Your answer should be compact. 0.13. What is the difference between the highest and the second highest Mineral Rent(as % of GDP) in Coal?
Make the answer very short. 0.01. What is the difference between the highest and the second highest Mineral Rent(as % of GDP) in Natural Gas?
Your response must be concise. 0.01. What is the difference between the highest and the second highest Mineral Rent(as % of GDP) of Oil?
Provide a short and direct response. 0.01. What is the difference between the highest and the second highest Mineral Rent(as % of GDP) in Other Minerals?
Ensure brevity in your answer.  0. What is the difference between the highest and the lowest Mineral Rent(as % of GDP) in Coal?
Keep it short and to the point. 0.02. What is the difference between the highest and the lowest Mineral Rent(as % of GDP) of Natural Gas?
Give a very brief answer. 0.09. What is the difference between the highest and the lowest Mineral Rent(as % of GDP) in Oil?
Keep it short and to the point. 0.19. What is the difference between the highest and the lowest Mineral Rent(as % of GDP) of Other Minerals?
Offer a very short reply. 0.01. 